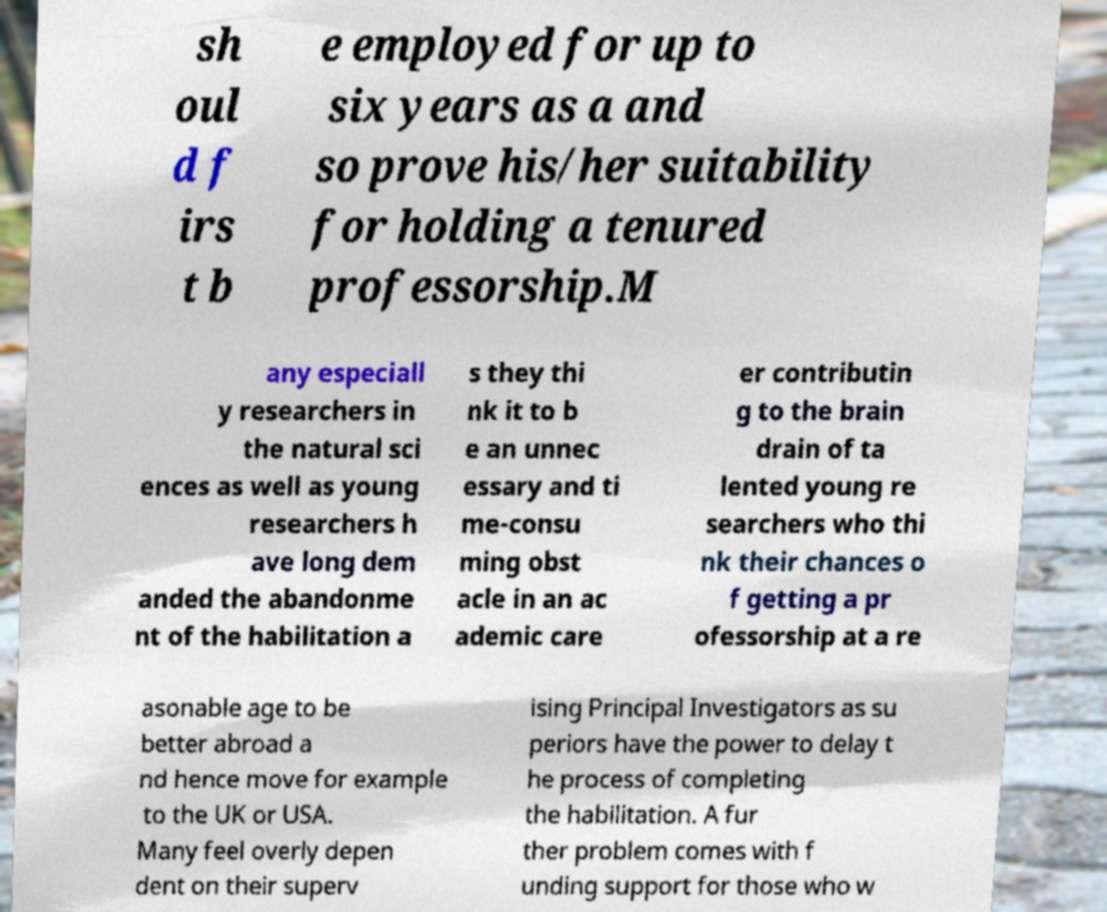There's text embedded in this image that I need extracted. Can you transcribe it verbatim? sh oul d f irs t b e employed for up to six years as a and so prove his/her suitability for holding a tenured professorship.M any especiall y researchers in the natural sci ences as well as young researchers h ave long dem anded the abandonme nt of the habilitation a s they thi nk it to b e an unnec essary and ti me-consu ming obst acle in an ac ademic care er contributin g to the brain drain of ta lented young re searchers who thi nk their chances o f getting a pr ofessorship at a re asonable age to be better abroad a nd hence move for example to the UK or USA. Many feel overly depen dent on their superv ising Principal Investigators as su periors have the power to delay t he process of completing the habilitation. A fur ther problem comes with f unding support for those who w 